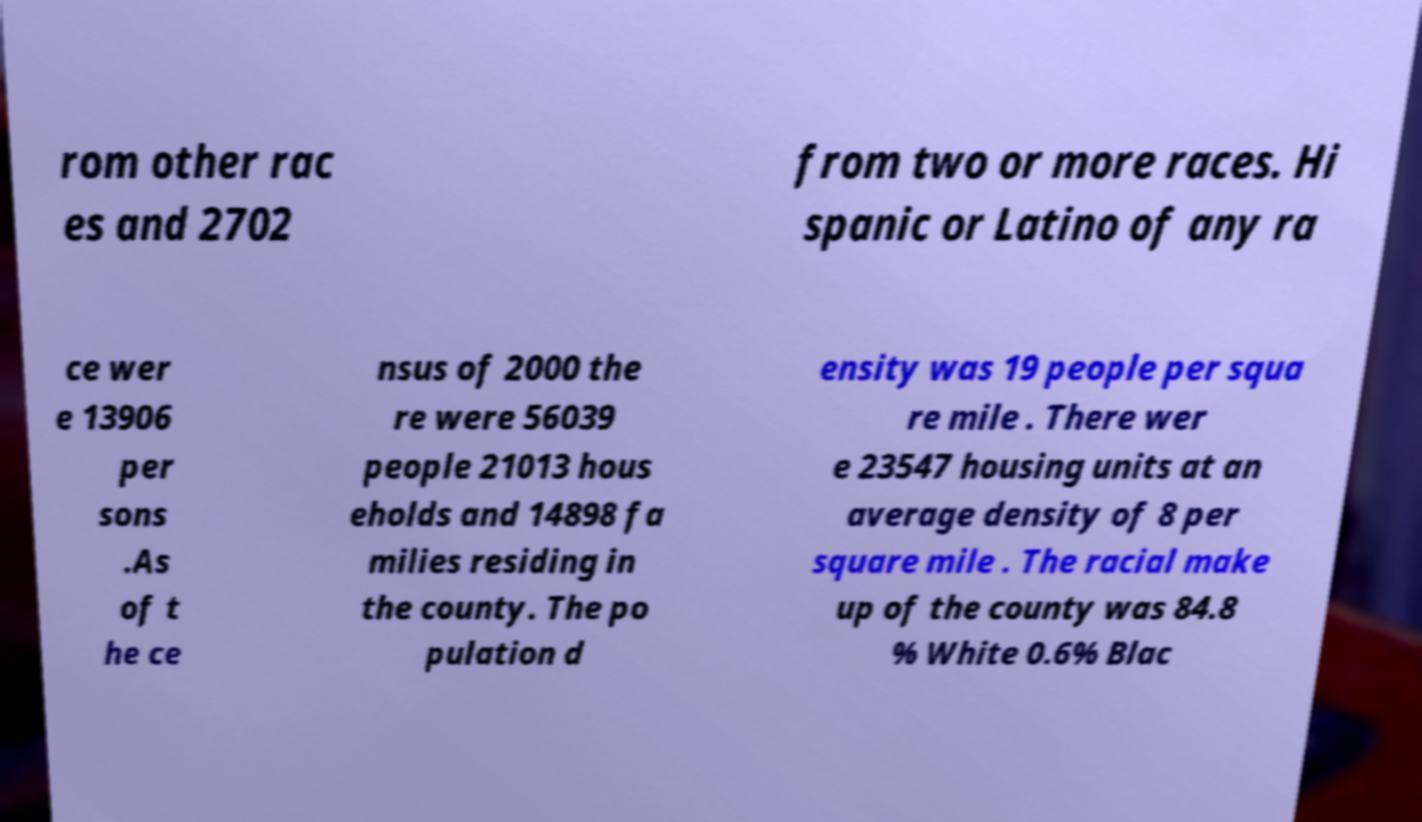For documentation purposes, I need the text within this image transcribed. Could you provide that? rom other rac es and 2702 from two or more races. Hi spanic or Latino of any ra ce wer e 13906 per sons .As of t he ce nsus of 2000 the re were 56039 people 21013 hous eholds and 14898 fa milies residing in the county. The po pulation d ensity was 19 people per squa re mile . There wer e 23547 housing units at an average density of 8 per square mile . The racial make up of the county was 84.8 % White 0.6% Blac 